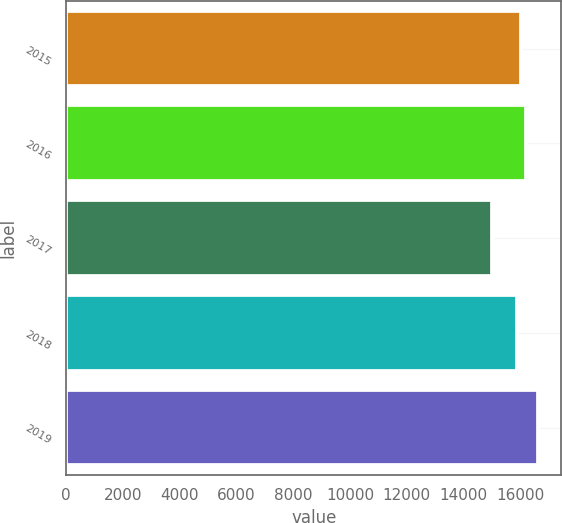Convert chart. <chart><loc_0><loc_0><loc_500><loc_500><bar_chart><fcel>2015<fcel>2016<fcel>2017<fcel>2018<fcel>2019<nl><fcel>16037.8<fcel>16199.6<fcel>15001<fcel>15876<fcel>16619<nl></chart> 